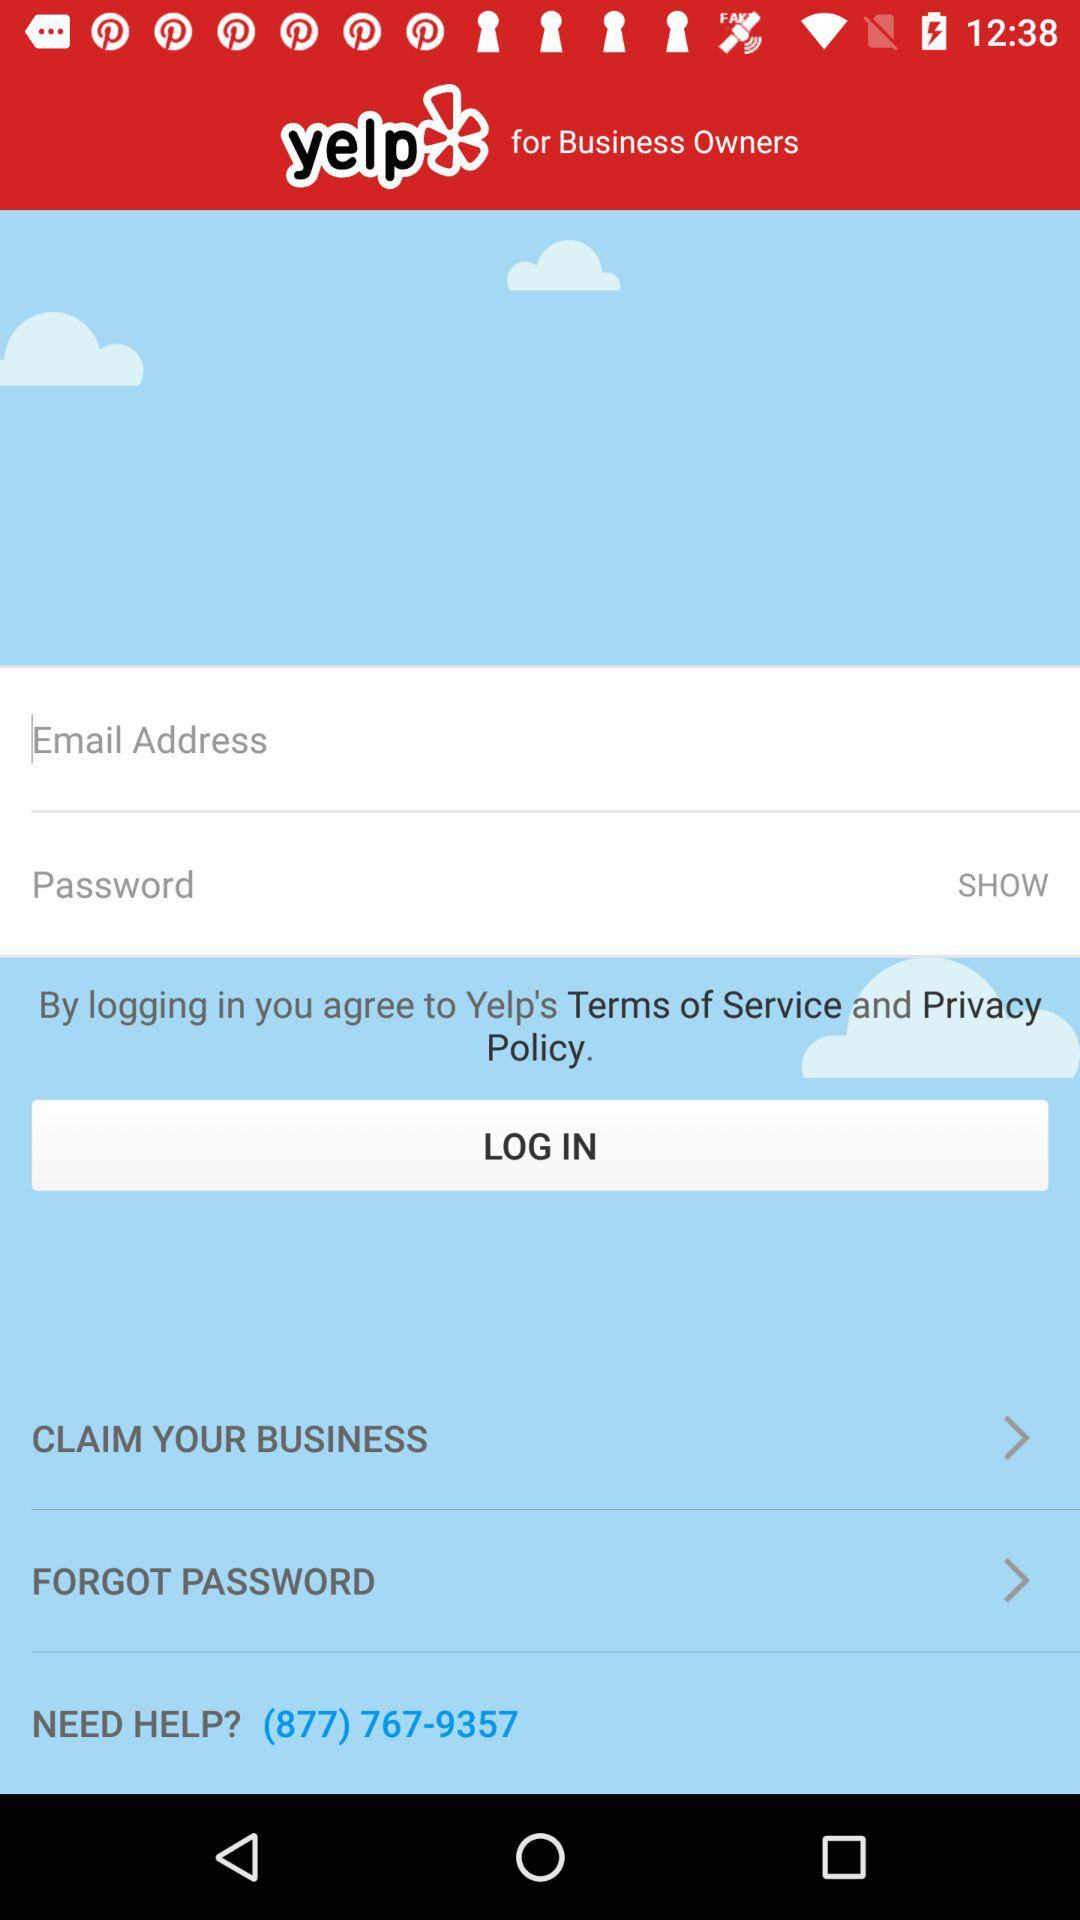What is the helpline number? The helpline number is (877) 767-9357. 